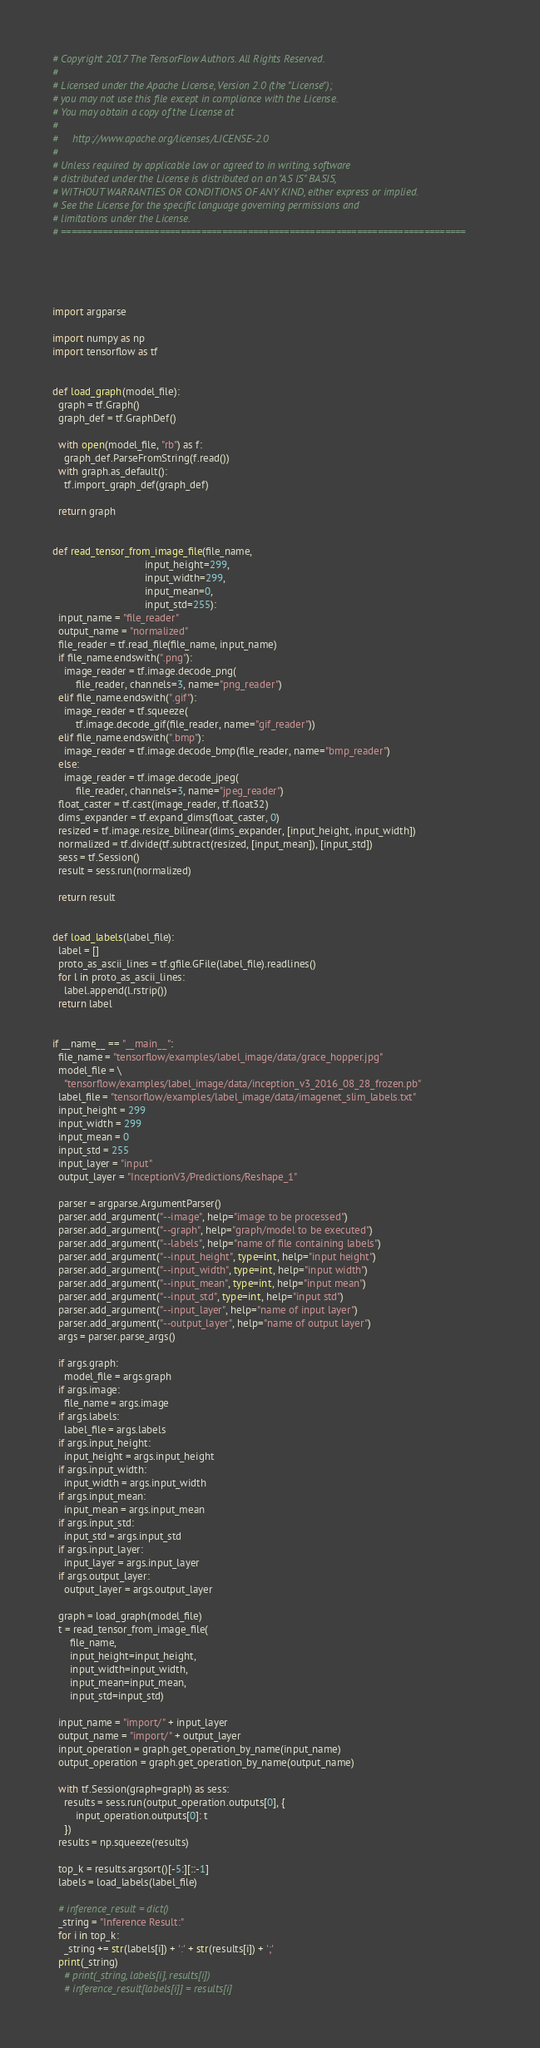<code> <loc_0><loc_0><loc_500><loc_500><_Python_># Copyright 2017 The TensorFlow Authors. All Rights Reserved.
#
# Licensed under the Apache License, Version 2.0 (the "License");
# you may not use this file except in compliance with the License.
# You may obtain a copy of the License at
#
#     http://www.apache.org/licenses/LICENSE-2.0
#
# Unless required by applicable law or agreed to in writing, software
# distributed under the License is distributed on an "AS IS" BASIS,
# WITHOUT WARRANTIES OR CONDITIONS OF ANY KIND, either express or implied.
# See the License for the specific language governing permissions and
# limitations under the License.
# ==============================================================================





import argparse

import numpy as np
import tensorflow as tf


def load_graph(model_file):
  graph = tf.Graph()
  graph_def = tf.GraphDef()

  with open(model_file, "rb") as f:
    graph_def.ParseFromString(f.read())
  with graph.as_default():
    tf.import_graph_def(graph_def)

  return graph


def read_tensor_from_image_file(file_name,
                                input_height=299,
                                input_width=299,
                                input_mean=0,
                                input_std=255):
  input_name = "file_reader"
  output_name = "normalized"
  file_reader = tf.read_file(file_name, input_name)
  if file_name.endswith(".png"):
    image_reader = tf.image.decode_png(
        file_reader, channels=3, name="png_reader")
  elif file_name.endswith(".gif"):
    image_reader = tf.squeeze(
        tf.image.decode_gif(file_reader, name="gif_reader"))
  elif file_name.endswith(".bmp"):
    image_reader = tf.image.decode_bmp(file_reader, name="bmp_reader")
  else:
    image_reader = tf.image.decode_jpeg(
        file_reader, channels=3, name="jpeg_reader")
  float_caster = tf.cast(image_reader, tf.float32)
  dims_expander = tf.expand_dims(float_caster, 0)
  resized = tf.image.resize_bilinear(dims_expander, [input_height, input_width])
  normalized = tf.divide(tf.subtract(resized, [input_mean]), [input_std])
  sess = tf.Session()
  result = sess.run(normalized)

  return result


def load_labels(label_file):
  label = []
  proto_as_ascii_lines = tf.gfile.GFile(label_file).readlines()
  for l in proto_as_ascii_lines:
    label.append(l.rstrip())
  return label


if __name__ == "__main__":
  file_name = "tensorflow/examples/label_image/data/grace_hopper.jpg"
  model_file = \
    "tensorflow/examples/label_image/data/inception_v3_2016_08_28_frozen.pb"
  label_file = "tensorflow/examples/label_image/data/imagenet_slim_labels.txt"
  input_height = 299
  input_width = 299
  input_mean = 0
  input_std = 255
  input_layer = "input"
  output_layer = "InceptionV3/Predictions/Reshape_1"

  parser = argparse.ArgumentParser()
  parser.add_argument("--image", help="image to be processed")
  parser.add_argument("--graph", help="graph/model to be executed")
  parser.add_argument("--labels", help="name of file containing labels")
  parser.add_argument("--input_height", type=int, help="input height")
  parser.add_argument("--input_width", type=int, help="input width")
  parser.add_argument("--input_mean", type=int, help="input mean")
  parser.add_argument("--input_std", type=int, help="input std")
  parser.add_argument("--input_layer", help="name of input layer")
  parser.add_argument("--output_layer", help="name of output layer")
  args = parser.parse_args()

  if args.graph:
    model_file = args.graph
  if args.image:
    file_name = args.image
  if args.labels:
    label_file = args.labels
  if args.input_height:
    input_height = args.input_height
  if args.input_width:
    input_width = args.input_width
  if args.input_mean:
    input_mean = args.input_mean
  if args.input_std:
    input_std = args.input_std
  if args.input_layer:
    input_layer = args.input_layer
  if args.output_layer:
    output_layer = args.output_layer

  graph = load_graph(model_file)
  t = read_tensor_from_image_file(
      file_name,
      input_height=input_height,
      input_width=input_width,
      input_mean=input_mean,
      input_std=input_std)

  input_name = "import/" + input_layer
  output_name = "import/" + output_layer
  input_operation = graph.get_operation_by_name(input_name)
  output_operation = graph.get_operation_by_name(output_name)

  with tf.Session(graph=graph) as sess:
    results = sess.run(output_operation.outputs[0], {
        input_operation.outputs[0]: t
    })
  results = np.squeeze(results)

  top_k = results.argsort()[-5:][::-1]
  labels = load_labels(label_file)

  # inference_result = dict()
  _string = "Inference Result:"
  for i in top_k:
    _string += str(labels[i]) + ':' + str(results[i]) + ';'
  print(_string)
    # print(_string, labels[i], results[i])
    # inference_result[labels[i]] = results[i]
</code> 